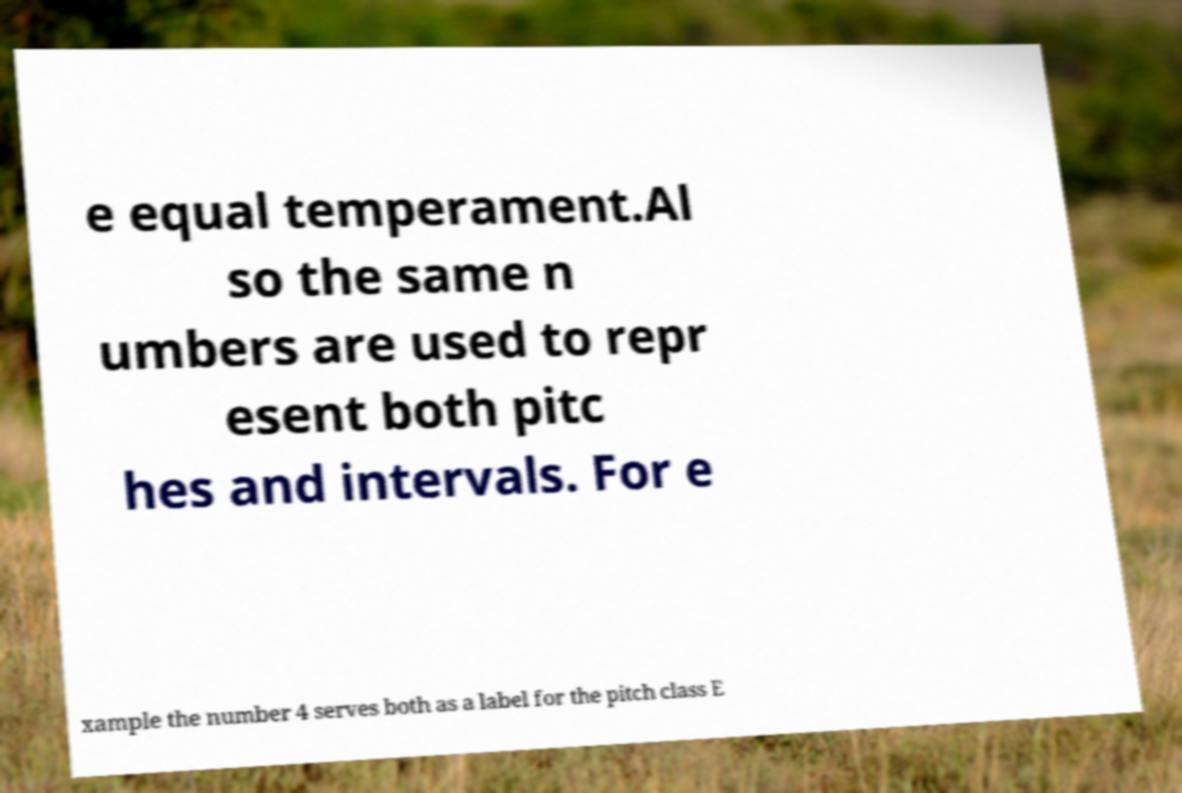Can you accurately transcribe the text from the provided image for me? e equal temperament.Al so the same n umbers are used to repr esent both pitc hes and intervals. For e xample the number 4 serves both as a label for the pitch class E 